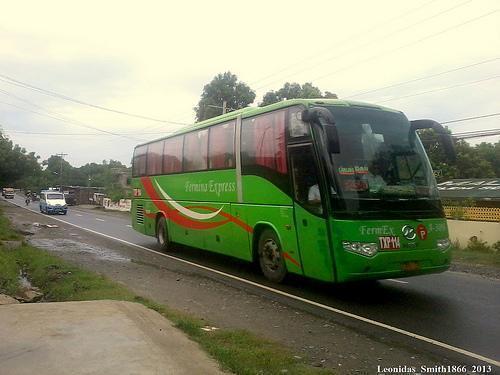How many buses are on the street?
Give a very brief answer. 1. 